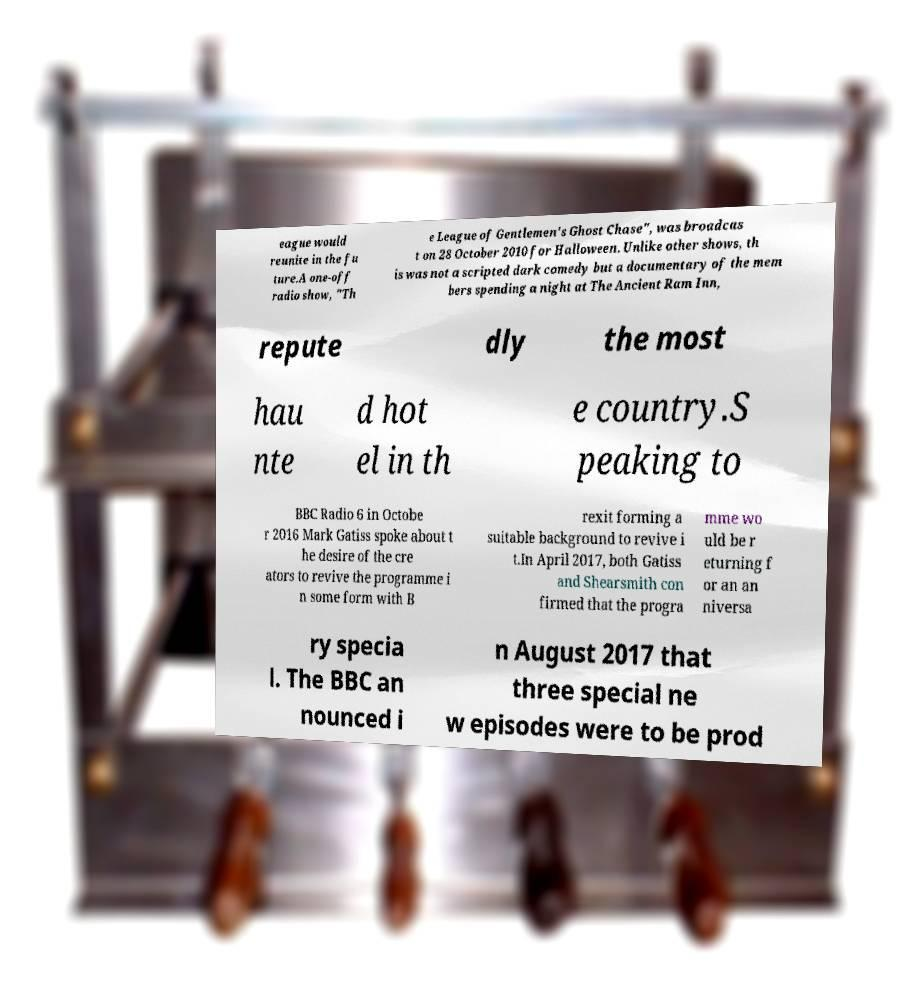Could you assist in decoding the text presented in this image and type it out clearly? eague would reunite in the fu ture.A one-off radio show, "Th e League of Gentlemen's Ghost Chase", was broadcas t on 28 October 2010 for Halloween. Unlike other shows, th is was not a scripted dark comedy but a documentary of the mem bers spending a night at The Ancient Ram Inn, repute dly the most hau nte d hot el in th e country.S peaking to BBC Radio 6 in Octobe r 2016 Mark Gatiss spoke about t he desire of the cre ators to revive the programme i n some form with B rexit forming a suitable background to revive i t.In April 2017, both Gatiss and Shearsmith con firmed that the progra mme wo uld be r eturning f or an an niversa ry specia l. The BBC an nounced i n August 2017 that three special ne w episodes were to be prod 